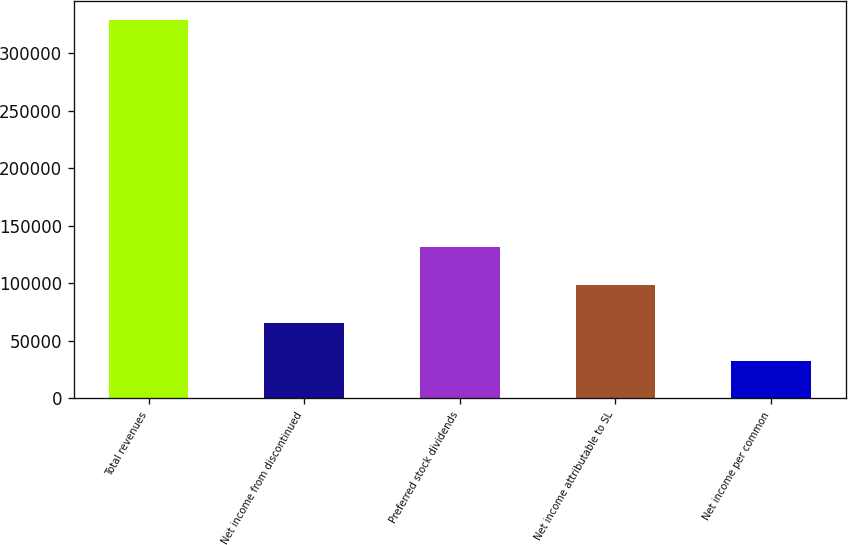Convert chart. <chart><loc_0><loc_0><loc_500><loc_500><bar_chart><fcel>Total revenues<fcel>Net income from discontinued<fcel>Preferred stock dividends<fcel>Net income attributable to SL<fcel>Net income per common<nl><fcel>328877<fcel>65775.4<fcel>131551<fcel>98663.1<fcel>32887.7<nl></chart> 